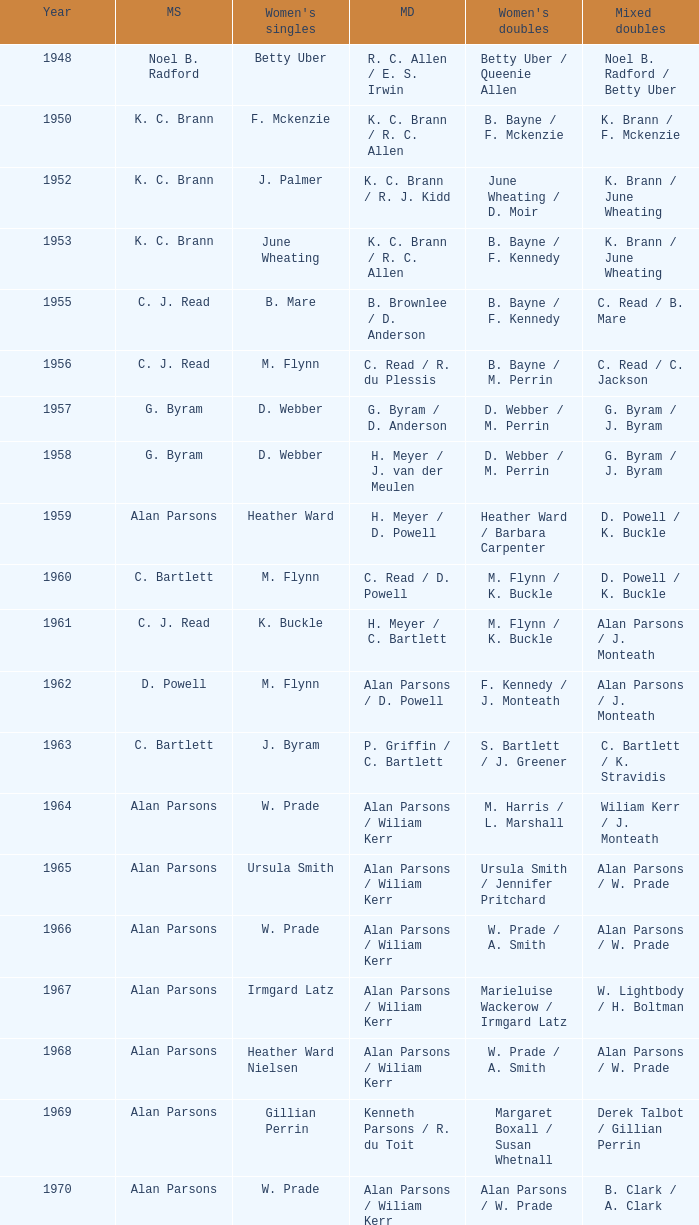Which Men's doubles have a Year smaller than 1960, and Men's singles of noel b. radford? R. C. Allen / E. S. Irwin. 